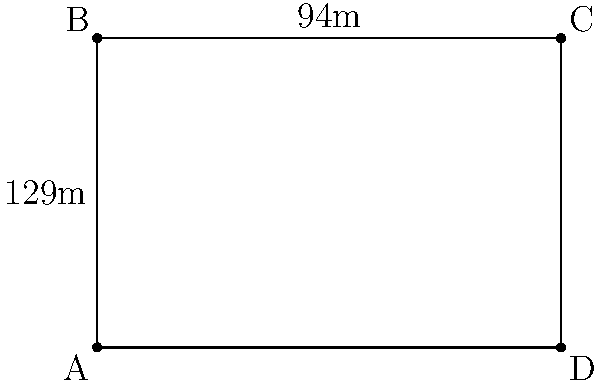As you lead a group through Madrid's historic center, you arrive at the famous Plaza Mayor. To give your tourists a sense of its size, you explain that its shape can be simplified to a rectangle. If the longer side measures 129 meters and the shorter side 94 meters, what is the perimeter of Plaza Mayor? To calculate the perimeter of Plaza Mayor using its simplified rectangular shape, we need to follow these steps:

1. Identify the given dimensions:
   - Longer side (length) = 129 meters
   - Shorter side (width) = 94 meters

2. Recall the formula for the perimeter of a rectangle:
   $$ P = 2l + 2w $$
   Where $P$ is the perimeter, $l$ is the length, and $w$ is the width.

3. Substitute the values into the formula:
   $$ P = 2(129) + 2(94) $$

4. Simplify:
   $$ P = 258 + 188 $$

5. Calculate the final result:
   $$ P = 446 $$

Therefore, the perimeter of the simplified rectangular shape of Plaza Mayor is 446 meters.
Answer: 446 meters 